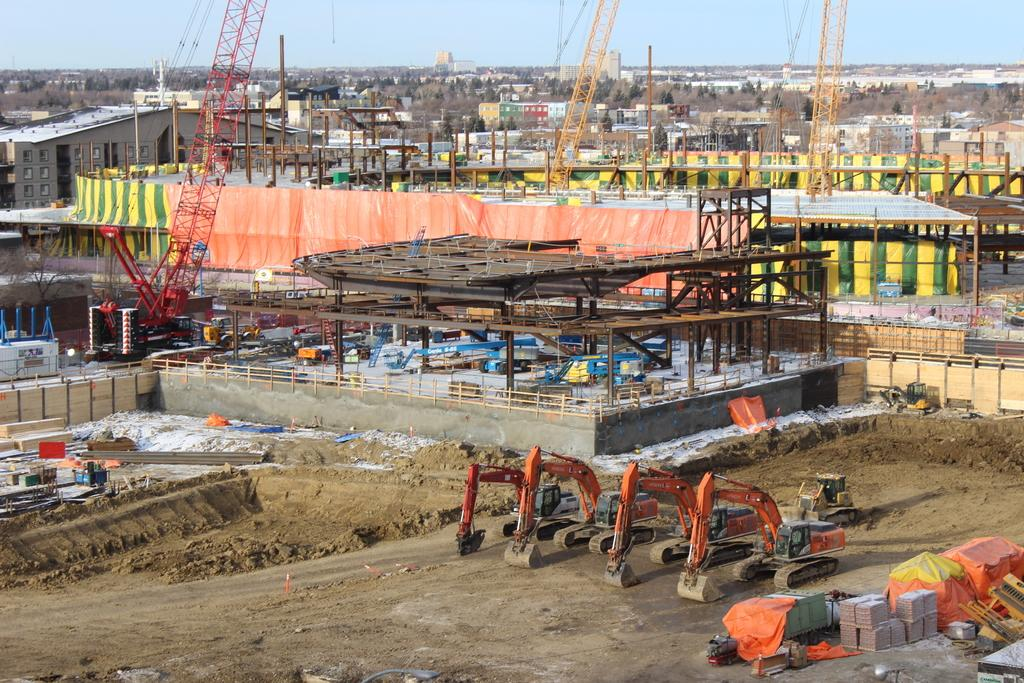What type of location is depicted in the image? The image is an aerial view of a construction site. What can be seen in the front of the image? There are cranes in the front of the image. What is the primary activity taking place at the site? There are many buildings under construction in the image. What part of the natural environment is visible in the image? The sky is visible in the image. What type of jewel can be seen in the image? There is no jewel present in the image; it is an aerial view of a construction site with cranes and buildings under construction. 